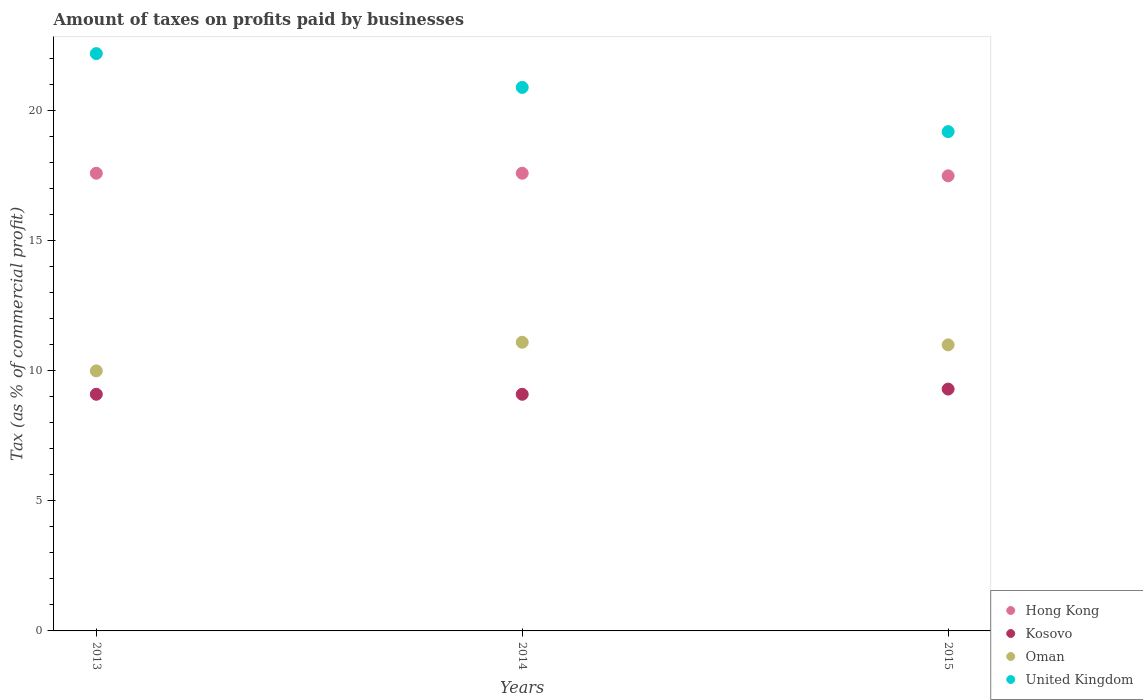How many different coloured dotlines are there?
Your answer should be compact. 4. Is the number of dotlines equal to the number of legend labels?
Offer a very short reply. Yes. What is the percentage of taxes paid by businesses in Kosovo in 2013?
Offer a very short reply. 9.1. Across all years, what is the maximum percentage of taxes paid by businesses in Hong Kong?
Your answer should be very brief. 17.6. Across all years, what is the minimum percentage of taxes paid by businesses in Kosovo?
Offer a terse response. 9.1. In which year was the percentage of taxes paid by businesses in Oman maximum?
Give a very brief answer. 2014. What is the total percentage of taxes paid by businesses in Kosovo in the graph?
Make the answer very short. 27.5. What is the difference between the percentage of taxes paid by businesses in United Kingdom in 2013 and that in 2014?
Your response must be concise. 1.3. What is the average percentage of taxes paid by businesses in Kosovo per year?
Your answer should be compact. 9.17. In how many years, is the percentage of taxes paid by businesses in Hong Kong greater than 3 %?
Your response must be concise. 3. What is the ratio of the percentage of taxes paid by businesses in Oman in 2013 to that in 2015?
Your answer should be compact. 0.91. Is the percentage of taxes paid by businesses in Oman in 2014 less than that in 2015?
Offer a very short reply. No. Is the difference between the percentage of taxes paid by businesses in United Kingdom in 2013 and 2015 greater than the difference between the percentage of taxes paid by businesses in Oman in 2013 and 2015?
Offer a very short reply. Yes. What is the difference between the highest and the second highest percentage of taxes paid by businesses in United Kingdom?
Ensure brevity in your answer.  1.3. What is the difference between the highest and the lowest percentage of taxes paid by businesses in Oman?
Give a very brief answer. 1.1. Is it the case that in every year, the sum of the percentage of taxes paid by businesses in Hong Kong and percentage of taxes paid by businesses in United Kingdom  is greater than the sum of percentage of taxes paid by businesses in Oman and percentage of taxes paid by businesses in Kosovo?
Offer a very short reply. Yes. Is the percentage of taxes paid by businesses in Oman strictly less than the percentage of taxes paid by businesses in Kosovo over the years?
Ensure brevity in your answer.  No. Does the graph contain any zero values?
Give a very brief answer. No. Does the graph contain grids?
Keep it short and to the point. No. Where does the legend appear in the graph?
Keep it short and to the point. Bottom right. What is the title of the graph?
Your answer should be very brief. Amount of taxes on profits paid by businesses. Does "Solomon Islands" appear as one of the legend labels in the graph?
Make the answer very short. No. What is the label or title of the Y-axis?
Make the answer very short. Tax (as % of commercial profit). What is the Tax (as % of commercial profit) of Hong Kong in 2013?
Your answer should be compact. 17.6. What is the Tax (as % of commercial profit) of Kosovo in 2013?
Provide a short and direct response. 9.1. What is the Tax (as % of commercial profit) of Oman in 2013?
Give a very brief answer. 10. What is the Tax (as % of commercial profit) in United Kingdom in 2013?
Make the answer very short. 22.2. What is the Tax (as % of commercial profit) of United Kingdom in 2014?
Offer a terse response. 20.9. What is the Tax (as % of commercial profit) of Kosovo in 2015?
Keep it short and to the point. 9.3. What is the Tax (as % of commercial profit) of Oman in 2015?
Make the answer very short. 11. Across all years, what is the maximum Tax (as % of commercial profit) in Hong Kong?
Give a very brief answer. 17.6. Across all years, what is the maximum Tax (as % of commercial profit) of Kosovo?
Keep it short and to the point. 9.3. Across all years, what is the maximum Tax (as % of commercial profit) in Oman?
Ensure brevity in your answer.  11.1. Across all years, what is the maximum Tax (as % of commercial profit) of United Kingdom?
Offer a terse response. 22.2. Across all years, what is the minimum Tax (as % of commercial profit) in Kosovo?
Provide a succinct answer. 9.1. What is the total Tax (as % of commercial profit) of Hong Kong in the graph?
Offer a very short reply. 52.7. What is the total Tax (as % of commercial profit) in Kosovo in the graph?
Offer a very short reply. 27.5. What is the total Tax (as % of commercial profit) of Oman in the graph?
Your response must be concise. 32.1. What is the total Tax (as % of commercial profit) of United Kingdom in the graph?
Your answer should be very brief. 62.3. What is the difference between the Tax (as % of commercial profit) in Hong Kong in 2013 and that in 2014?
Your answer should be very brief. 0. What is the difference between the Tax (as % of commercial profit) in Kosovo in 2013 and that in 2014?
Provide a short and direct response. 0. What is the difference between the Tax (as % of commercial profit) of Kosovo in 2013 and that in 2015?
Make the answer very short. -0.2. What is the difference between the Tax (as % of commercial profit) of Oman in 2013 and that in 2015?
Your answer should be very brief. -1. What is the difference between the Tax (as % of commercial profit) of United Kingdom in 2013 and that in 2015?
Keep it short and to the point. 3. What is the difference between the Tax (as % of commercial profit) of Kosovo in 2014 and that in 2015?
Keep it short and to the point. -0.2. What is the difference between the Tax (as % of commercial profit) in United Kingdom in 2014 and that in 2015?
Keep it short and to the point. 1.7. What is the difference between the Tax (as % of commercial profit) in Hong Kong in 2013 and the Tax (as % of commercial profit) in Kosovo in 2014?
Keep it short and to the point. 8.5. What is the difference between the Tax (as % of commercial profit) of Kosovo in 2013 and the Tax (as % of commercial profit) of Oman in 2014?
Provide a short and direct response. -2. What is the difference between the Tax (as % of commercial profit) in Kosovo in 2013 and the Tax (as % of commercial profit) in United Kingdom in 2014?
Give a very brief answer. -11.8. What is the difference between the Tax (as % of commercial profit) of Oman in 2013 and the Tax (as % of commercial profit) of United Kingdom in 2014?
Ensure brevity in your answer.  -10.9. What is the difference between the Tax (as % of commercial profit) of Hong Kong in 2013 and the Tax (as % of commercial profit) of United Kingdom in 2015?
Keep it short and to the point. -1.6. What is the difference between the Tax (as % of commercial profit) in Kosovo in 2013 and the Tax (as % of commercial profit) in Oman in 2015?
Give a very brief answer. -1.9. What is the difference between the Tax (as % of commercial profit) of Hong Kong in 2014 and the Tax (as % of commercial profit) of Kosovo in 2015?
Your answer should be compact. 8.3. What is the difference between the Tax (as % of commercial profit) of Kosovo in 2014 and the Tax (as % of commercial profit) of Oman in 2015?
Offer a very short reply. -1.9. What is the average Tax (as % of commercial profit) in Hong Kong per year?
Make the answer very short. 17.57. What is the average Tax (as % of commercial profit) of Kosovo per year?
Offer a very short reply. 9.17. What is the average Tax (as % of commercial profit) in United Kingdom per year?
Your response must be concise. 20.77. In the year 2013, what is the difference between the Tax (as % of commercial profit) in Hong Kong and Tax (as % of commercial profit) in Kosovo?
Provide a short and direct response. 8.5. In the year 2013, what is the difference between the Tax (as % of commercial profit) of Hong Kong and Tax (as % of commercial profit) of United Kingdom?
Keep it short and to the point. -4.6. In the year 2013, what is the difference between the Tax (as % of commercial profit) in Kosovo and Tax (as % of commercial profit) in Oman?
Offer a very short reply. -0.9. In the year 2013, what is the difference between the Tax (as % of commercial profit) in Kosovo and Tax (as % of commercial profit) in United Kingdom?
Provide a succinct answer. -13.1. In the year 2013, what is the difference between the Tax (as % of commercial profit) of Oman and Tax (as % of commercial profit) of United Kingdom?
Your answer should be very brief. -12.2. In the year 2014, what is the difference between the Tax (as % of commercial profit) of Hong Kong and Tax (as % of commercial profit) of Oman?
Your answer should be very brief. 6.5. In the year 2014, what is the difference between the Tax (as % of commercial profit) of Oman and Tax (as % of commercial profit) of United Kingdom?
Give a very brief answer. -9.8. In the year 2015, what is the difference between the Tax (as % of commercial profit) in Hong Kong and Tax (as % of commercial profit) in Kosovo?
Your response must be concise. 8.2. In the year 2015, what is the difference between the Tax (as % of commercial profit) in Hong Kong and Tax (as % of commercial profit) in Oman?
Ensure brevity in your answer.  6.5. In the year 2015, what is the difference between the Tax (as % of commercial profit) of Oman and Tax (as % of commercial profit) of United Kingdom?
Give a very brief answer. -8.2. What is the ratio of the Tax (as % of commercial profit) in Hong Kong in 2013 to that in 2014?
Provide a succinct answer. 1. What is the ratio of the Tax (as % of commercial profit) in Oman in 2013 to that in 2014?
Your answer should be very brief. 0.9. What is the ratio of the Tax (as % of commercial profit) of United Kingdom in 2013 to that in 2014?
Offer a very short reply. 1.06. What is the ratio of the Tax (as % of commercial profit) in Hong Kong in 2013 to that in 2015?
Make the answer very short. 1.01. What is the ratio of the Tax (as % of commercial profit) of Kosovo in 2013 to that in 2015?
Ensure brevity in your answer.  0.98. What is the ratio of the Tax (as % of commercial profit) in United Kingdom in 2013 to that in 2015?
Give a very brief answer. 1.16. What is the ratio of the Tax (as % of commercial profit) of Hong Kong in 2014 to that in 2015?
Your answer should be very brief. 1.01. What is the ratio of the Tax (as % of commercial profit) of Kosovo in 2014 to that in 2015?
Provide a succinct answer. 0.98. What is the ratio of the Tax (as % of commercial profit) in Oman in 2014 to that in 2015?
Keep it short and to the point. 1.01. What is the ratio of the Tax (as % of commercial profit) in United Kingdom in 2014 to that in 2015?
Give a very brief answer. 1.09. What is the difference between the highest and the second highest Tax (as % of commercial profit) of United Kingdom?
Your answer should be very brief. 1.3. What is the difference between the highest and the lowest Tax (as % of commercial profit) of Kosovo?
Your answer should be very brief. 0.2. What is the difference between the highest and the lowest Tax (as % of commercial profit) of Oman?
Keep it short and to the point. 1.1. What is the difference between the highest and the lowest Tax (as % of commercial profit) in United Kingdom?
Provide a succinct answer. 3. 